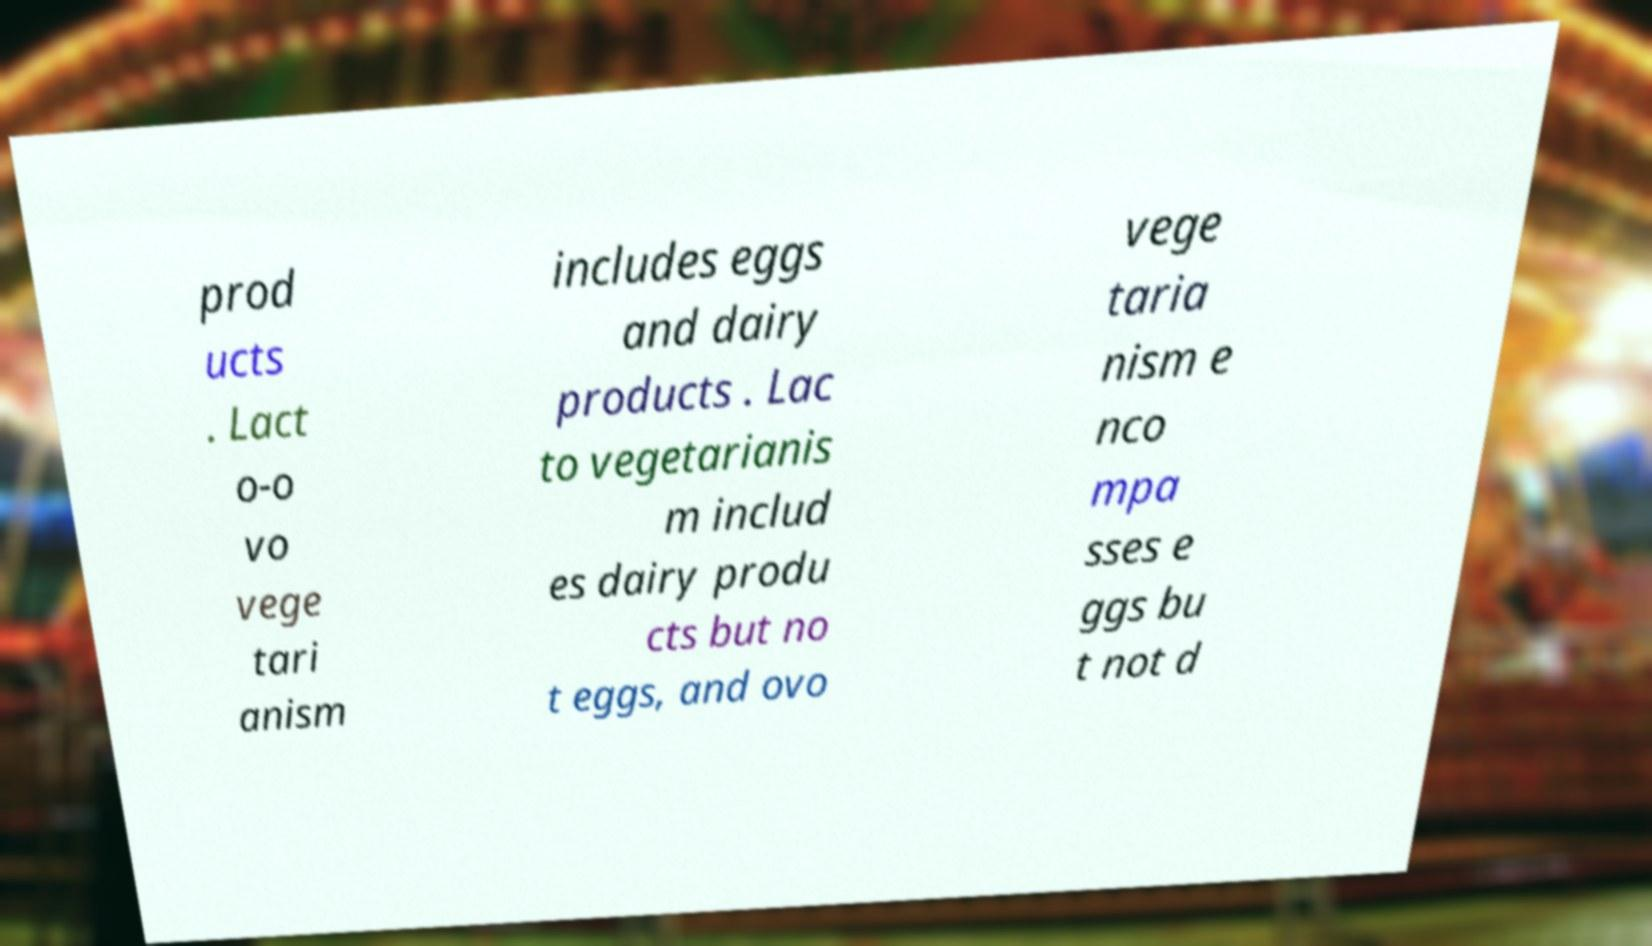There's text embedded in this image that I need extracted. Can you transcribe it verbatim? prod ucts . Lact o-o vo vege tari anism includes eggs and dairy products . Lac to vegetarianis m includ es dairy produ cts but no t eggs, and ovo vege taria nism e nco mpa sses e ggs bu t not d 